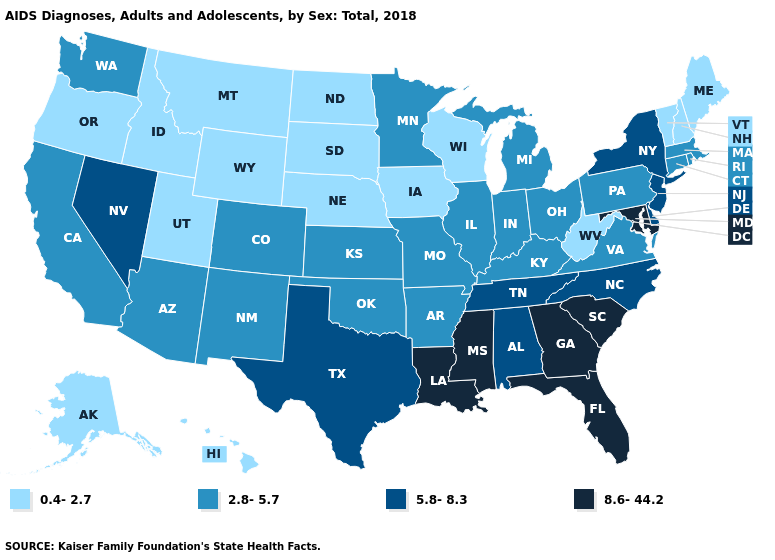What is the value of North Carolina?
Answer briefly. 5.8-8.3. Which states hav the highest value in the MidWest?
Write a very short answer. Illinois, Indiana, Kansas, Michigan, Minnesota, Missouri, Ohio. Among the states that border Tennessee , does Alabama have the highest value?
Concise answer only. No. What is the value of Nevada?
Give a very brief answer. 5.8-8.3. Which states hav the highest value in the West?
Write a very short answer. Nevada. Name the states that have a value in the range 0.4-2.7?
Give a very brief answer. Alaska, Hawaii, Idaho, Iowa, Maine, Montana, Nebraska, New Hampshire, North Dakota, Oregon, South Dakota, Utah, Vermont, West Virginia, Wisconsin, Wyoming. How many symbols are there in the legend?
Be succinct. 4. Name the states that have a value in the range 8.6-44.2?
Short answer required. Florida, Georgia, Louisiana, Maryland, Mississippi, South Carolina. Which states have the highest value in the USA?
Concise answer only. Florida, Georgia, Louisiana, Maryland, Mississippi, South Carolina. Name the states that have a value in the range 8.6-44.2?
Write a very short answer. Florida, Georgia, Louisiana, Maryland, Mississippi, South Carolina. What is the lowest value in states that border Arizona?
Answer briefly. 0.4-2.7. Name the states that have a value in the range 2.8-5.7?
Short answer required. Arizona, Arkansas, California, Colorado, Connecticut, Illinois, Indiana, Kansas, Kentucky, Massachusetts, Michigan, Minnesota, Missouri, New Mexico, Ohio, Oklahoma, Pennsylvania, Rhode Island, Virginia, Washington. Among the states that border Oregon , does Idaho have the lowest value?
Short answer required. Yes. Name the states that have a value in the range 0.4-2.7?
Be succinct. Alaska, Hawaii, Idaho, Iowa, Maine, Montana, Nebraska, New Hampshire, North Dakota, Oregon, South Dakota, Utah, Vermont, West Virginia, Wisconsin, Wyoming. Name the states that have a value in the range 8.6-44.2?
Quick response, please. Florida, Georgia, Louisiana, Maryland, Mississippi, South Carolina. 